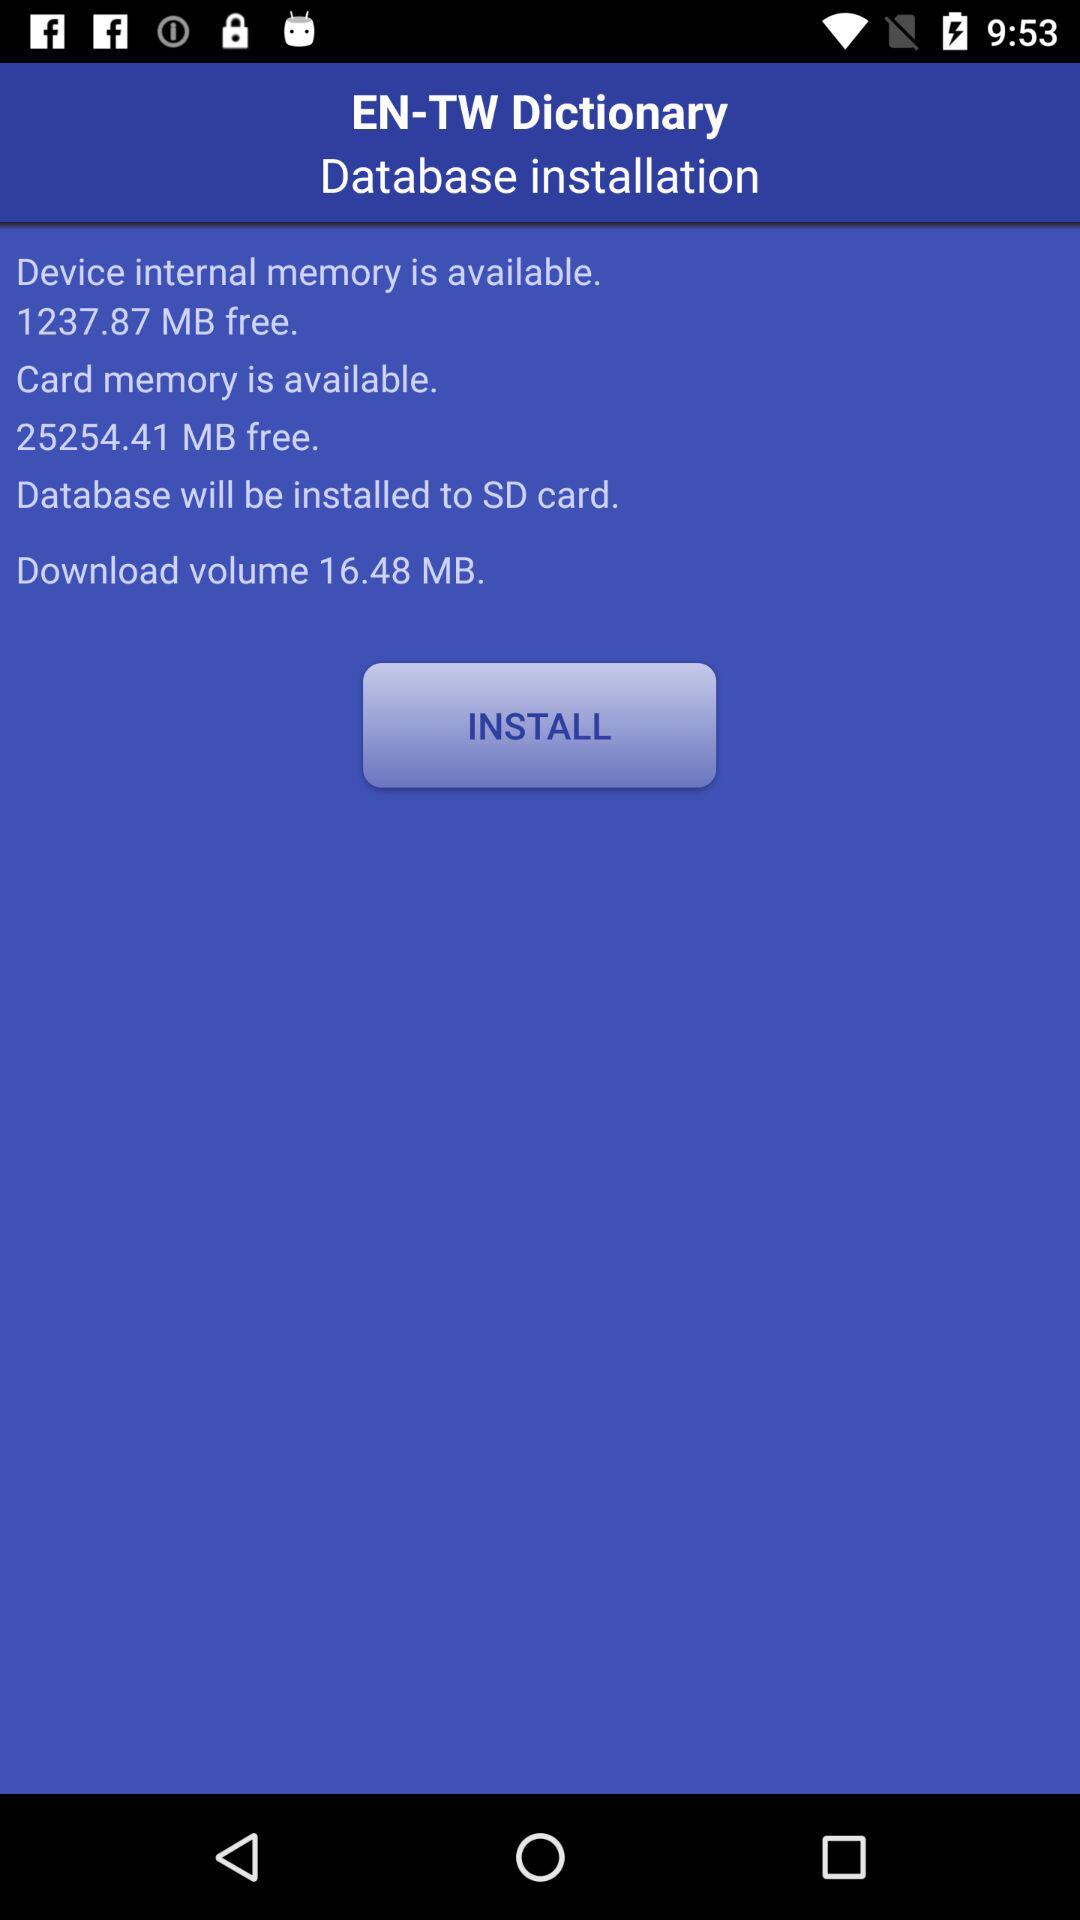What is the download volume? The download volume is 16.48 mb. 